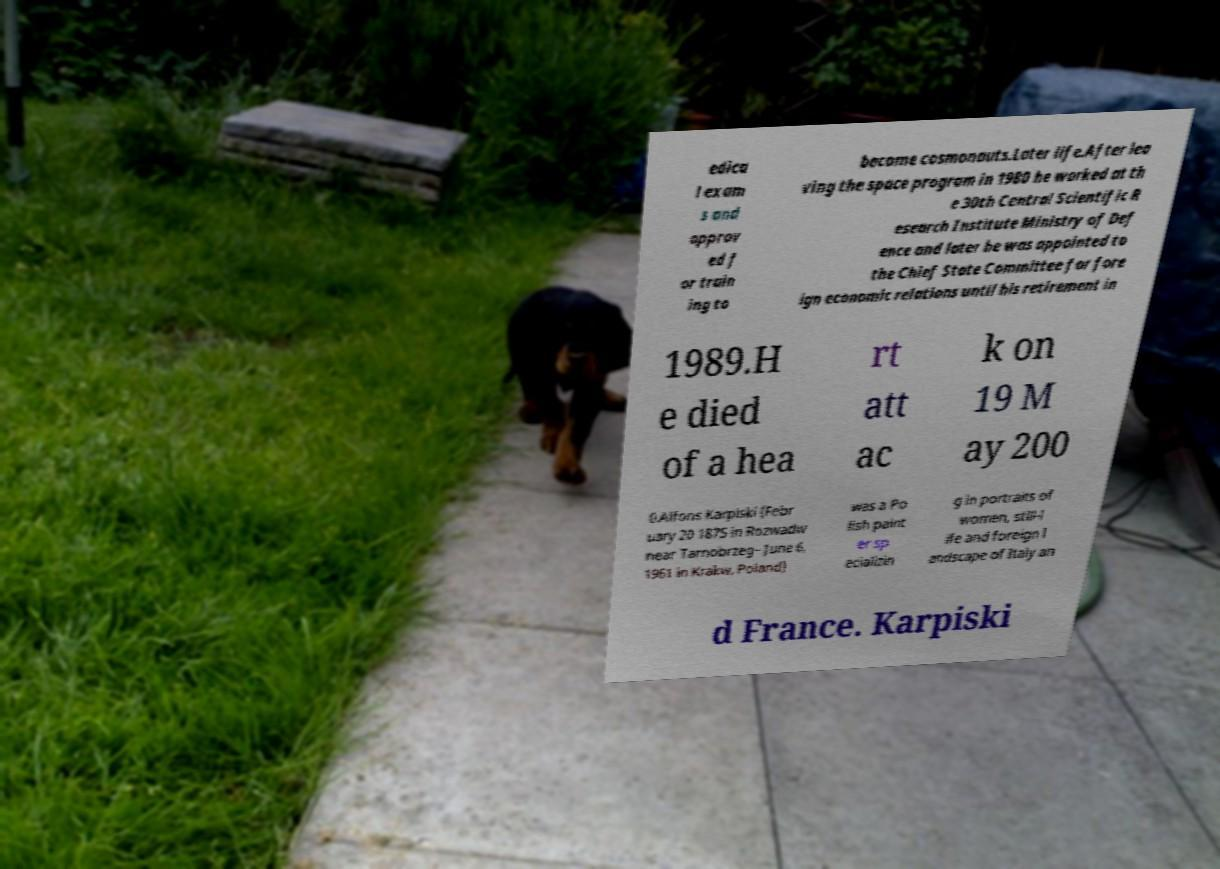For documentation purposes, I need the text within this image transcribed. Could you provide that? edica l exam s and approv ed f or train ing to become cosmonauts.Later life.After lea ving the space program in 1980 he worked at th e 30th Central Scientific R esearch Institute Ministry of Def ence and later he was appointed to the Chief State Committee for fore ign economic relations until his retirement in 1989.H e died of a hea rt att ac k on 19 M ay 200 0.Alfons Karpiski (Febr uary 20 1875 in Rozwadw near Tarnobrzeg– June 6, 1961 in Krakw, Poland) was a Po lish paint er sp ecializin g in portraits of women, still-l ife and foreign l andscape of Italy an d France. Karpiski 